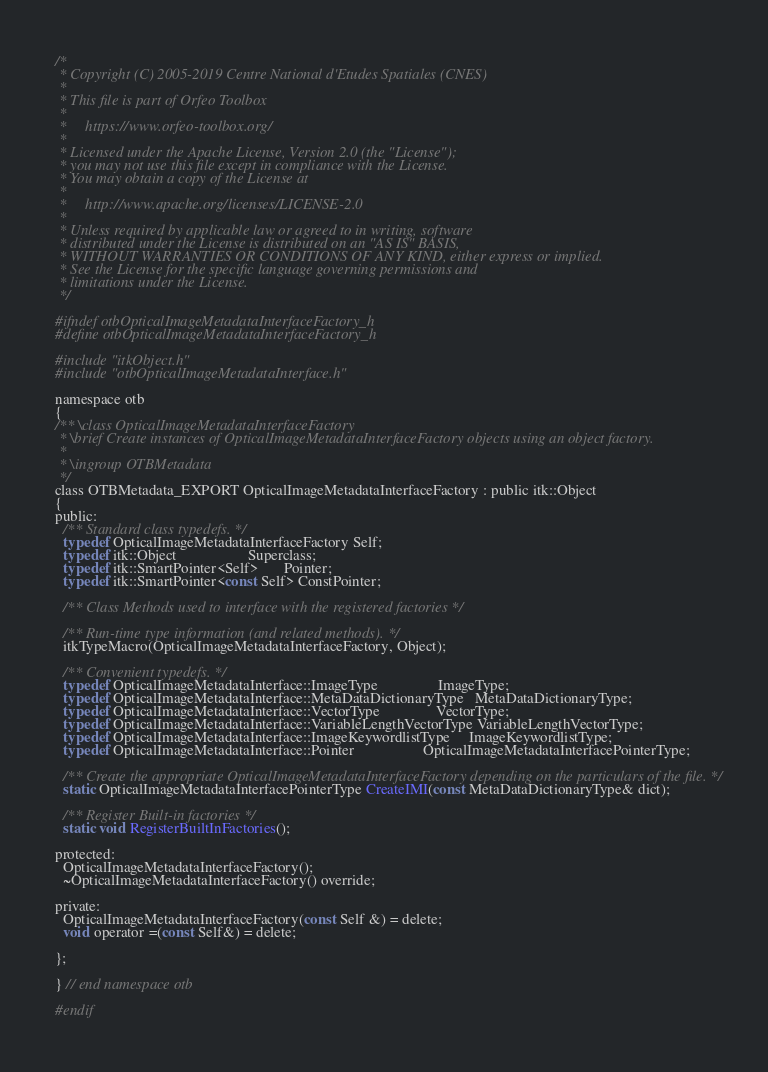Convert code to text. <code><loc_0><loc_0><loc_500><loc_500><_C_>/*
 * Copyright (C) 2005-2019 Centre National d'Etudes Spatiales (CNES)
 *
 * This file is part of Orfeo Toolbox
 *
 *     https://www.orfeo-toolbox.org/
 *
 * Licensed under the Apache License, Version 2.0 (the "License");
 * you may not use this file except in compliance with the License.
 * You may obtain a copy of the License at
 *
 *     http://www.apache.org/licenses/LICENSE-2.0
 *
 * Unless required by applicable law or agreed to in writing, software
 * distributed under the License is distributed on an "AS IS" BASIS,
 * WITHOUT WARRANTIES OR CONDITIONS OF ANY KIND, either express or implied.
 * See the License for the specific language governing permissions and
 * limitations under the License.
 */

#ifndef otbOpticalImageMetadataInterfaceFactory_h
#define otbOpticalImageMetadataInterfaceFactory_h

#include "itkObject.h"
#include "otbOpticalImageMetadataInterface.h"

namespace otb
{
/** \class OpticalImageMetadataInterfaceFactory
 * \brief Create instances of OpticalImageMetadataInterfaceFactory objects using an object factory.
 *
 * \ingroup OTBMetadata
 */
class OTBMetadata_EXPORT OpticalImageMetadataInterfaceFactory : public itk::Object
{
public:
  /** Standard class typedefs. */
  typedef OpticalImageMetadataInterfaceFactory Self;
  typedef itk::Object                   Superclass;
  typedef itk::SmartPointer<Self>       Pointer;
  typedef itk::SmartPointer<const Self> ConstPointer;

  /** Class Methods used to interface with the registered factories */

  /** Run-time type information (and related methods). */
  itkTypeMacro(OpticalImageMetadataInterfaceFactory, Object);

  /** Convenient typedefs. */
  typedef OpticalImageMetadataInterface::ImageType                ImageType;
  typedef OpticalImageMetadataInterface::MetaDataDictionaryType   MetaDataDictionaryType;
  typedef OpticalImageMetadataInterface::VectorType               VectorType;
  typedef OpticalImageMetadataInterface::VariableLengthVectorType VariableLengthVectorType;
  typedef OpticalImageMetadataInterface::ImageKeywordlistType     ImageKeywordlistType;
  typedef OpticalImageMetadataInterface::Pointer                  OpticalImageMetadataInterfacePointerType;

  /** Create the appropriate OpticalImageMetadataInterfaceFactory depending on the particulars of the file. */
  static OpticalImageMetadataInterfacePointerType CreateIMI(const MetaDataDictionaryType& dict);

  /** Register Built-in factories */
  static void RegisterBuiltInFactories();

protected:
  OpticalImageMetadataInterfaceFactory();
  ~OpticalImageMetadataInterfaceFactory() override;

private:
  OpticalImageMetadataInterfaceFactory(const Self &) = delete;
  void operator =(const Self&) = delete;

};

} // end namespace otb

#endif
</code> 